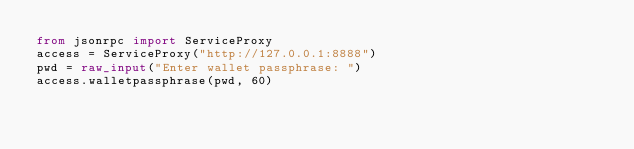<code> <loc_0><loc_0><loc_500><loc_500><_Python_>from jsonrpc import ServiceProxy
access = ServiceProxy("http://127.0.0.1:8888")
pwd = raw_input("Enter wallet passphrase: ")
access.walletpassphrase(pwd, 60)
</code> 